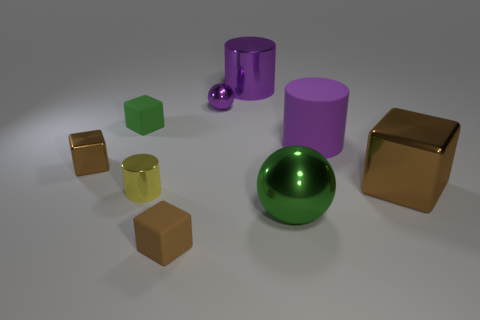What number of things are cylinders in front of the purple sphere or tiny cubes?
Your answer should be very brief. 5. There is a brown metallic block on the right side of the big green shiny thing; what is its size?
Your response must be concise. Large. What material is the tiny sphere?
Provide a succinct answer. Metal. What is the shape of the matte thing that is to the right of the tiny brown cube that is on the right side of the green rubber cube?
Ensure brevity in your answer.  Cylinder. How many other things are the same shape as the green metal thing?
Keep it short and to the point. 1. Are there any cylinders in front of the large purple metallic thing?
Your answer should be compact. Yes. The big metal cube is what color?
Offer a terse response. Brown. Do the big metal sphere and the metallic cylinder left of the tiny metallic sphere have the same color?
Your response must be concise. No. Is there another green thing of the same size as the green matte thing?
Your answer should be very brief. No. What is the size of the rubber cylinder that is the same color as the small ball?
Offer a terse response. Large. 